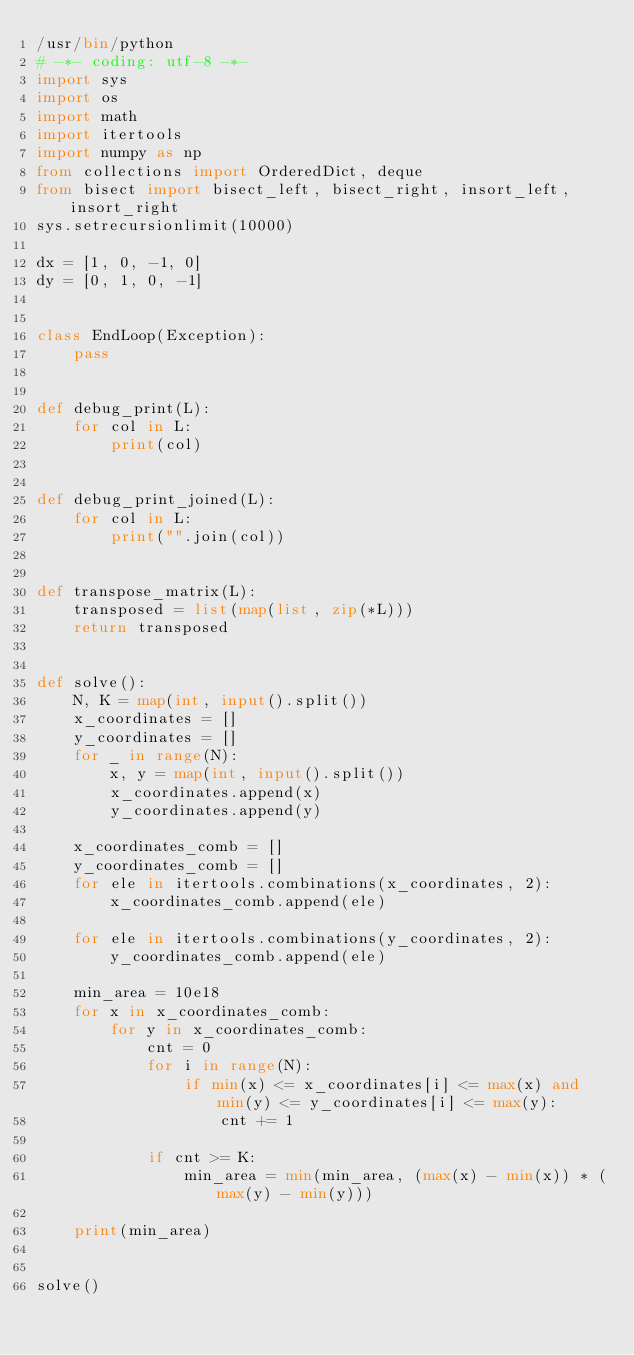<code> <loc_0><loc_0><loc_500><loc_500><_Python_>/usr/bin/python
# -*- coding: utf-8 -*-
import sys
import os
import math
import itertools
import numpy as np
from collections import OrderedDict, deque
from bisect import bisect_left, bisect_right, insort_left, insort_right
sys.setrecursionlimit(10000)

dx = [1, 0, -1, 0]
dy = [0, 1, 0, -1]


class EndLoop(Exception):
    pass


def debug_print(L):
    for col in L:
        print(col)


def debug_print_joined(L):
    for col in L:
        print("".join(col))


def transpose_matrix(L):
    transposed = list(map(list, zip(*L)))
    return transposed


def solve():
    N, K = map(int, input().split())
    x_coordinates = []
    y_coordinates = []
    for _ in range(N):
        x, y = map(int, input().split())
        x_coordinates.append(x)
        y_coordinates.append(y)

    x_coordinates_comb = []
    y_coordinates_comb = []
    for ele in itertools.combinations(x_coordinates, 2):
        x_coordinates_comb.append(ele)

    for ele in itertools.combinations(y_coordinates, 2):
        y_coordinates_comb.append(ele)

    min_area = 10e18
    for x in x_coordinates_comb:
        for y in x_coordinates_comb:
            cnt = 0
            for i in range(N):
                if min(x) <= x_coordinates[i] <= max(x) and min(y) <= y_coordinates[i] <= max(y):
                    cnt += 1

            if cnt >= K:
                min_area = min(min_area, (max(x) - min(x)) * (max(y) - min(y)))

    print(min_area)


solve()</code> 